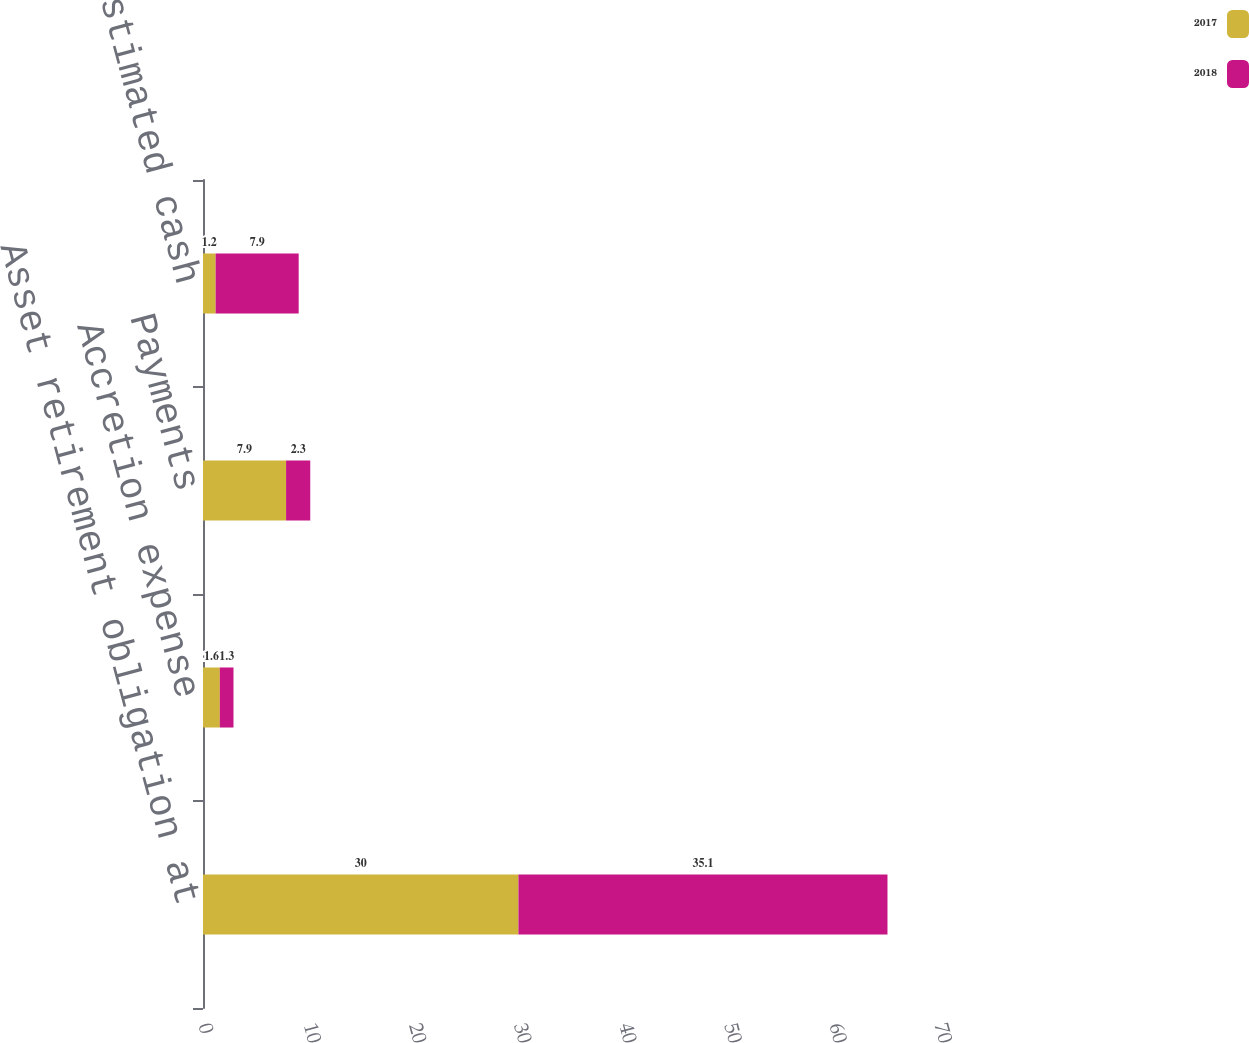Convert chart to OTSL. <chart><loc_0><loc_0><loc_500><loc_500><stacked_bar_chart><ecel><fcel>Asset retirement obligation at<fcel>Accretion expense<fcel>Payments<fcel>Revisions in estimated cash<nl><fcel>2017<fcel>30<fcel>1.6<fcel>7.9<fcel>1.2<nl><fcel>2018<fcel>35.1<fcel>1.3<fcel>2.3<fcel>7.9<nl></chart> 